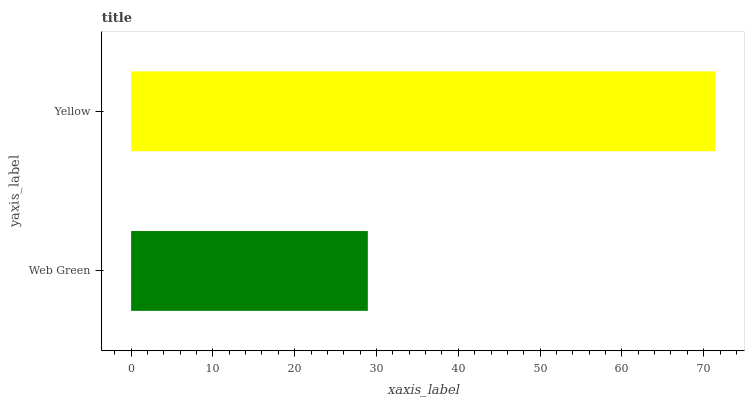Is Web Green the minimum?
Answer yes or no. Yes. Is Yellow the maximum?
Answer yes or no. Yes. Is Yellow the minimum?
Answer yes or no. No. Is Yellow greater than Web Green?
Answer yes or no. Yes. Is Web Green less than Yellow?
Answer yes or no. Yes. Is Web Green greater than Yellow?
Answer yes or no. No. Is Yellow less than Web Green?
Answer yes or no. No. Is Yellow the high median?
Answer yes or no. Yes. Is Web Green the low median?
Answer yes or no. Yes. Is Web Green the high median?
Answer yes or no. No. Is Yellow the low median?
Answer yes or no. No. 